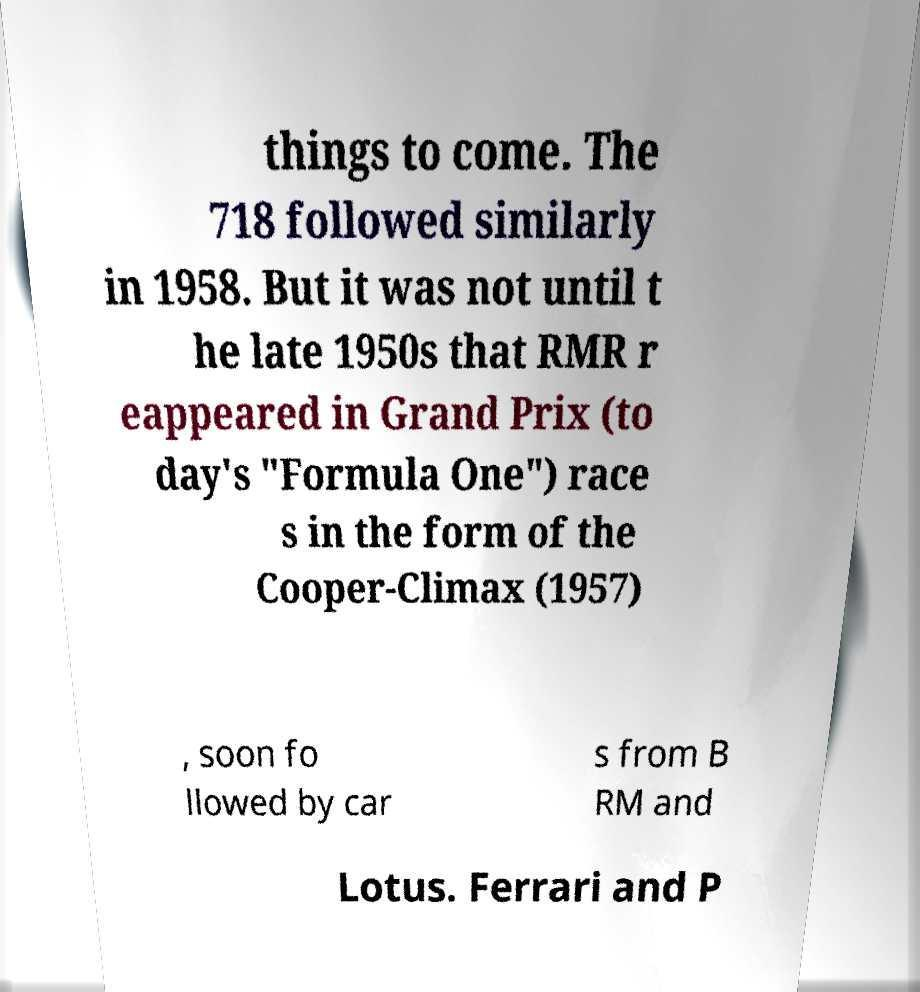What messages or text are displayed in this image? I need them in a readable, typed format. things to come. The 718 followed similarly in 1958. But it was not until t he late 1950s that RMR r eappeared in Grand Prix (to day's "Formula One") race s in the form of the Cooper-Climax (1957) , soon fo llowed by car s from B RM and Lotus. Ferrari and P 